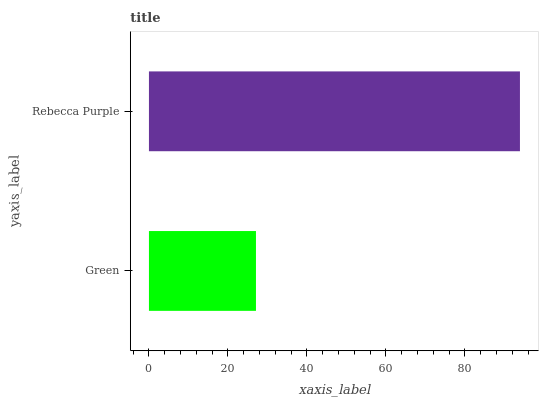Is Green the minimum?
Answer yes or no. Yes. Is Rebecca Purple the maximum?
Answer yes or no. Yes. Is Rebecca Purple the minimum?
Answer yes or no. No. Is Rebecca Purple greater than Green?
Answer yes or no. Yes. Is Green less than Rebecca Purple?
Answer yes or no. Yes. Is Green greater than Rebecca Purple?
Answer yes or no. No. Is Rebecca Purple less than Green?
Answer yes or no. No. Is Rebecca Purple the high median?
Answer yes or no. Yes. Is Green the low median?
Answer yes or no. Yes. Is Green the high median?
Answer yes or no. No. Is Rebecca Purple the low median?
Answer yes or no. No. 